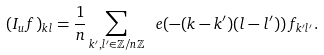Convert formula to latex. <formula><loc_0><loc_0><loc_500><loc_500>( I _ { u } f ) _ { k l } = \frac { 1 } { n } \sum _ { k ^ { \prime } , l ^ { \prime } \in \mathbb { Z } / n \mathbb { Z } } \ e ( - ( k - k ^ { \prime } ) ( l - l ^ { \prime } ) ) \, f _ { k ^ { \prime } l ^ { \prime } } .</formula> 